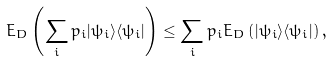Convert formula to latex. <formula><loc_0><loc_0><loc_500><loc_500>E _ { D } \left ( \sum _ { i } p _ { i } | \psi _ { i } \rangle \langle \psi _ { i } | \right ) \leq \sum _ { i } p _ { i } E _ { D } \left ( | \psi _ { i } \rangle \langle \psi _ { i } | \right ) ,</formula> 